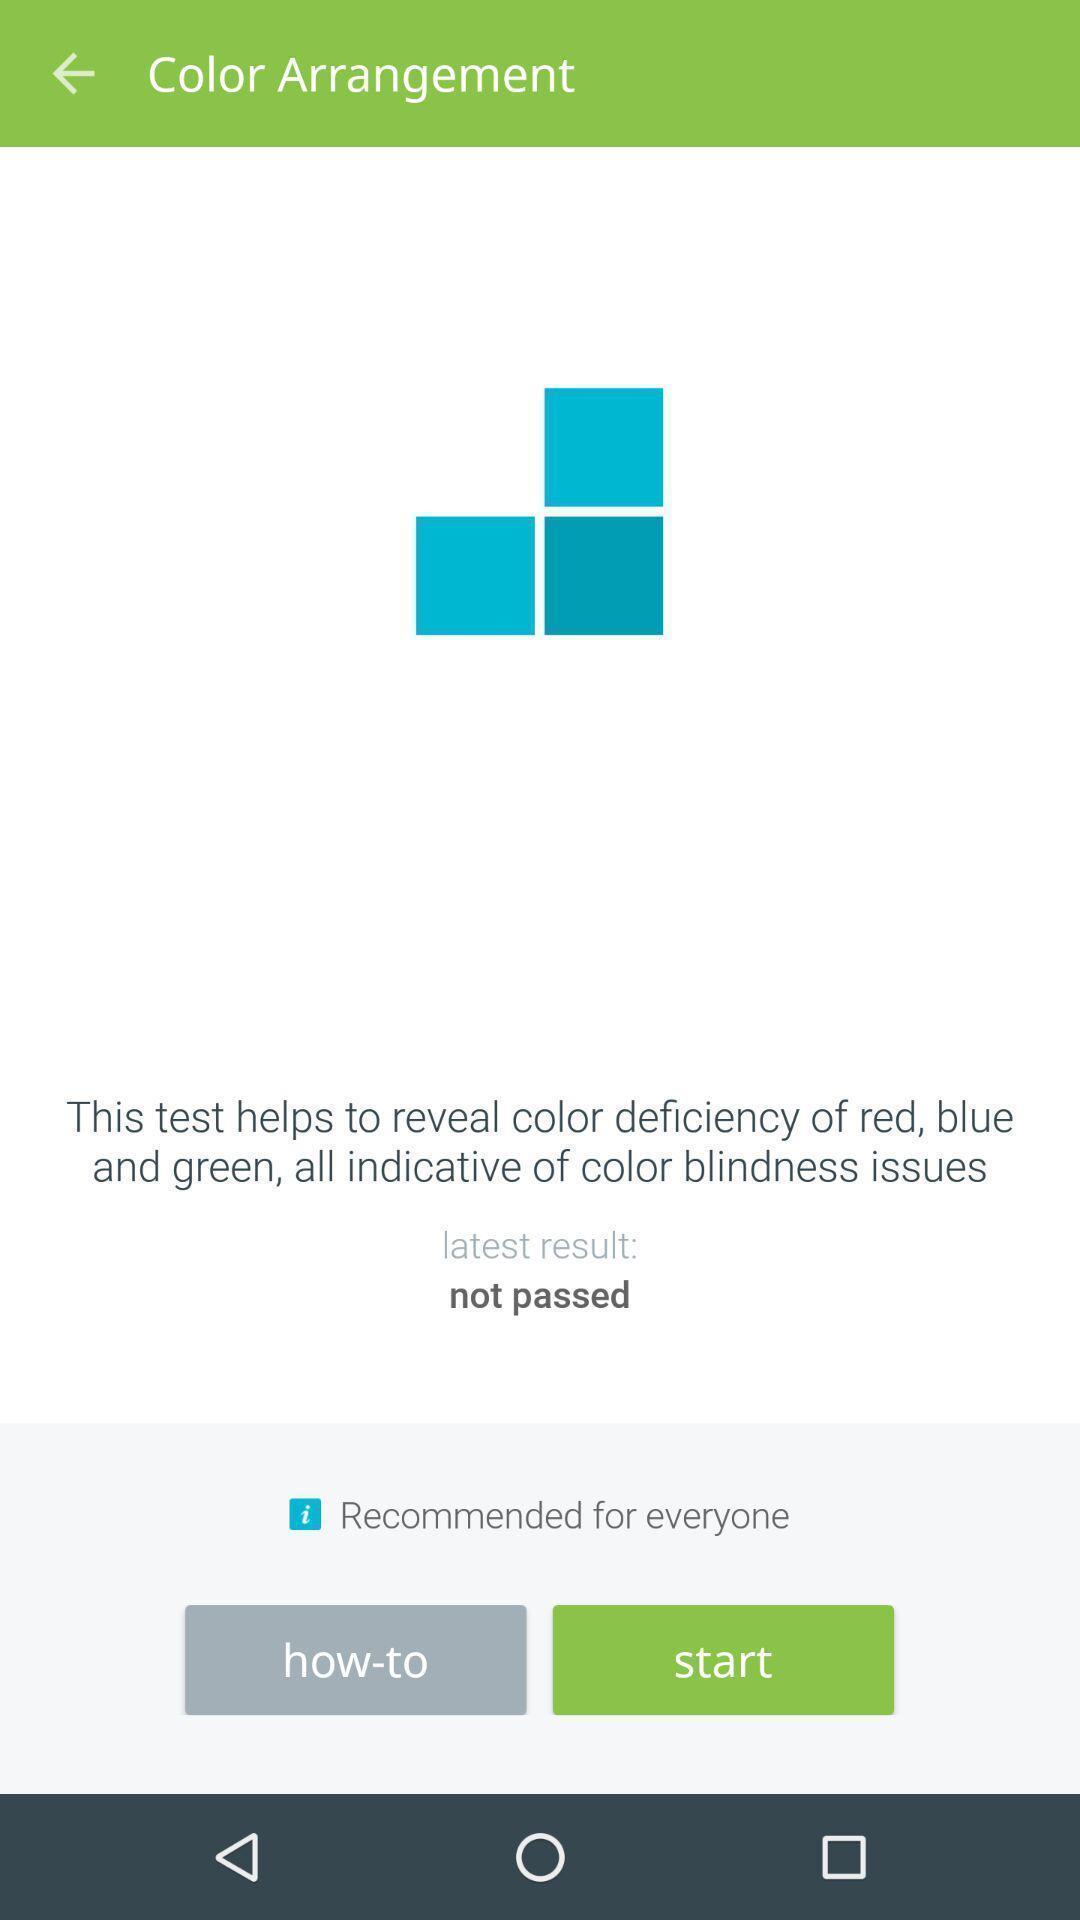Explain what's happening in this screen capture. Start button showing in this page. 